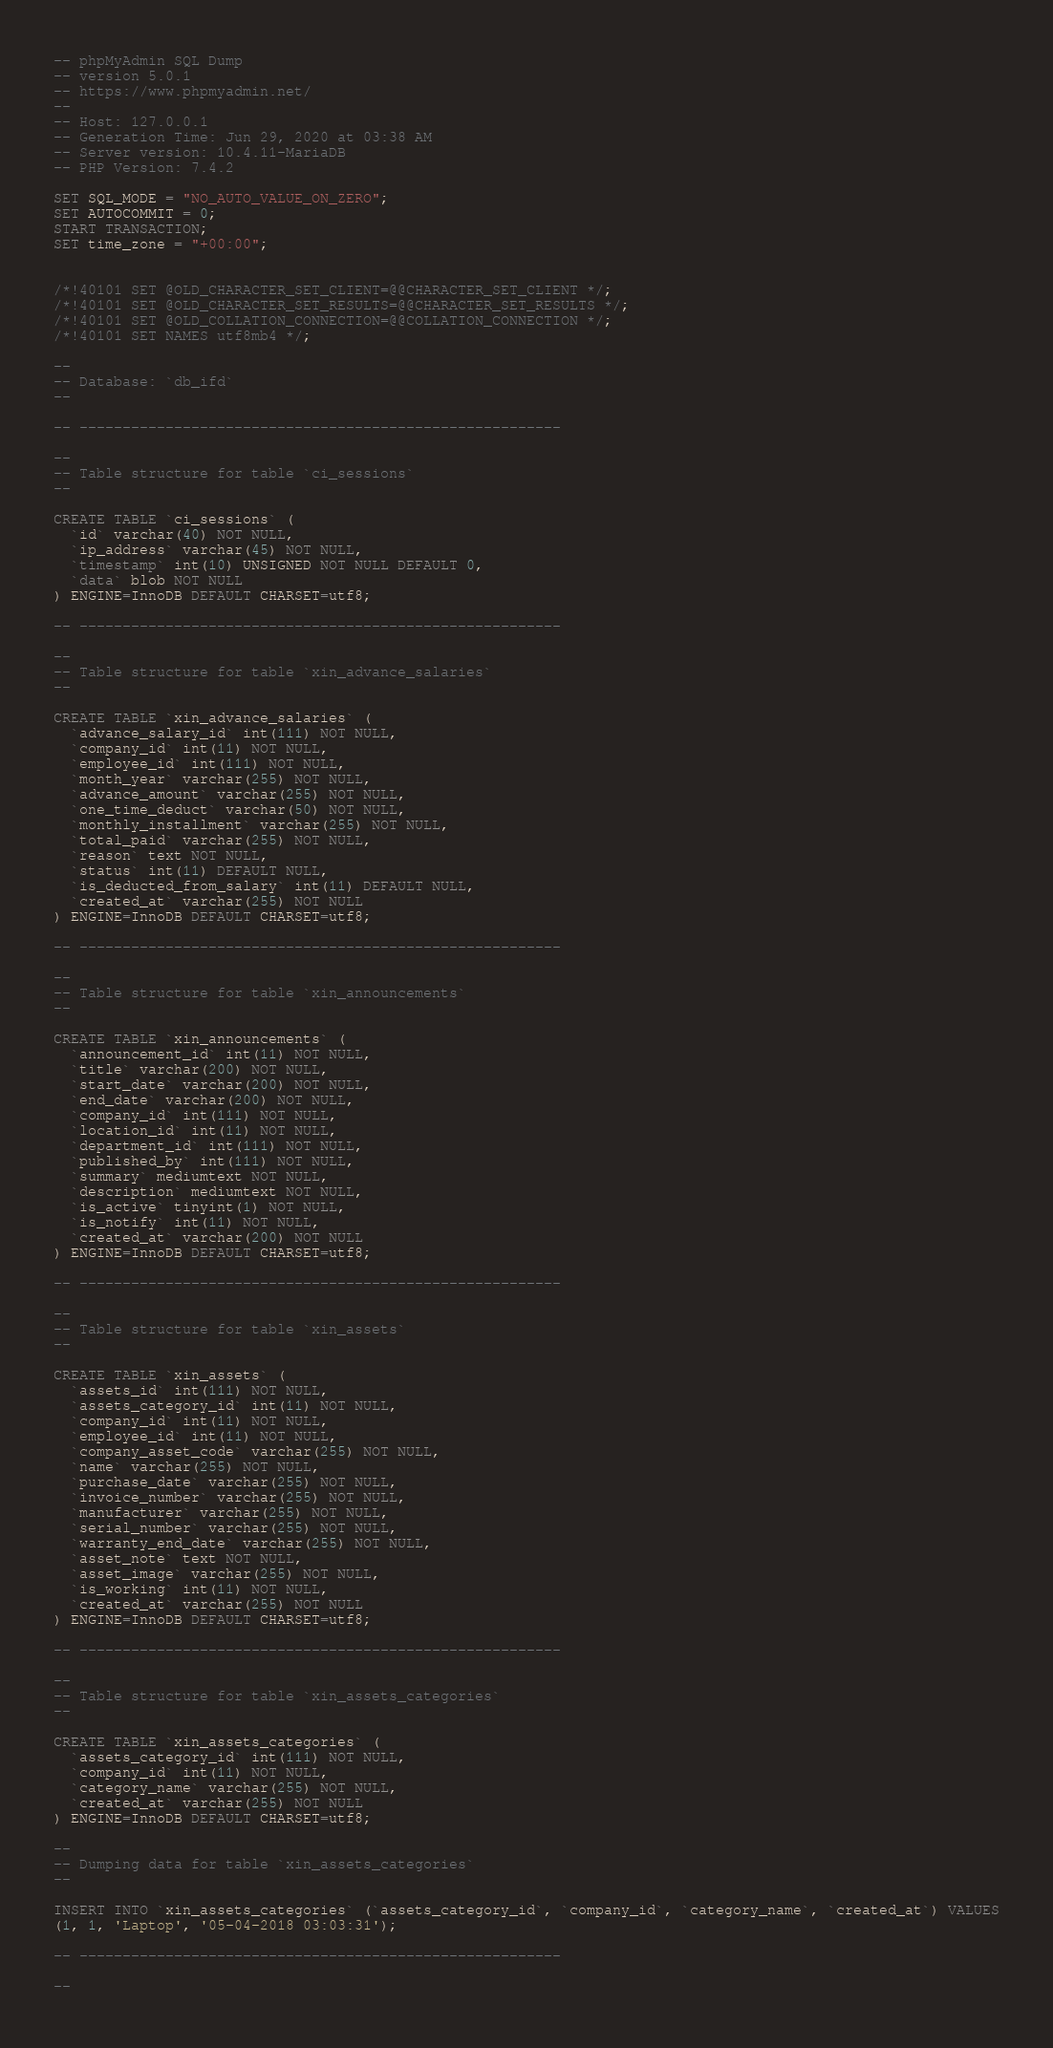<code> <loc_0><loc_0><loc_500><loc_500><_SQL_>-- phpMyAdmin SQL Dump
-- version 5.0.1
-- https://www.phpmyadmin.net/
--
-- Host: 127.0.0.1
-- Generation Time: Jun 29, 2020 at 03:38 AM
-- Server version: 10.4.11-MariaDB
-- PHP Version: 7.4.2

SET SQL_MODE = "NO_AUTO_VALUE_ON_ZERO";
SET AUTOCOMMIT = 0;
START TRANSACTION;
SET time_zone = "+00:00";


/*!40101 SET @OLD_CHARACTER_SET_CLIENT=@@CHARACTER_SET_CLIENT */;
/*!40101 SET @OLD_CHARACTER_SET_RESULTS=@@CHARACTER_SET_RESULTS */;
/*!40101 SET @OLD_COLLATION_CONNECTION=@@COLLATION_CONNECTION */;
/*!40101 SET NAMES utf8mb4 */;

--
-- Database: `db_ifd`
--

-- --------------------------------------------------------

--
-- Table structure for table `ci_sessions`
--

CREATE TABLE `ci_sessions` (
  `id` varchar(40) NOT NULL,
  `ip_address` varchar(45) NOT NULL,
  `timestamp` int(10) UNSIGNED NOT NULL DEFAULT 0,
  `data` blob NOT NULL
) ENGINE=InnoDB DEFAULT CHARSET=utf8;

-- --------------------------------------------------------

--
-- Table structure for table `xin_advance_salaries`
--

CREATE TABLE `xin_advance_salaries` (
  `advance_salary_id` int(111) NOT NULL,
  `company_id` int(11) NOT NULL,
  `employee_id` int(111) NOT NULL,
  `month_year` varchar(255) NOT NULL,
  `advance_amount` varchar(255) NOT NULL,
  `one_time_deduct` varchar(50) NOT NULL,
  `monthly_installment` varchar(255) NOT NULL,
  `total_paid` varchar(255) NOT NULL,
  `reason` text NOT NULL,
  `status` int(11) DEFAULT NULL,
  `is_deducted_from_salary` int(11) DEFAULT NULL,
  `created_at` varchar(255) NOT NULL
) ENGINE=InnoDB DEFAULT CHARSET=utf8;

-- --------------------------------------------------------

--
-- Table structure for table `xin_announcements`
--

CREATE TABLE `xin_announcements` (
  `announcement_id` int(11) NOT NULL,
  `title` varchar(200) NOT NULL,
  `start_date` varchar(200) NOT NULL,
  `end_date` varchar(200) NOT NULL,
  `company_id` int(111) NOT NULL,
  `location_id` int(11) NOT NULL,
  `department_id` int(111) NOT NULL,
  `published_by` int(111) NOT NULL,
  `summary` mediumtext NOT NULL,
  `description` mediumtext NOT NULL,
  `is_active` tinyint(1) NOT NULL,
  `is_notify` int(11) NOT NULL,
  `created_at` varchar(200) NOT NULL
) ENGINE=InnoDB DEFAULT CHARSET=utf8;

-- --------------------------------------------------------

--
-- Table structure for table `xin_assets`
--

CREATE TABLE `xin_assets` (
  `assets_id` int(111) NOT NULL,
  `assets_category_id` int(11) NOT NULL,
  `company_id` int(11) NOT NULL,
  `employee_id` int(11) NOT NULL,
  `company_asset_code` varchar(255) NOT NULL,
  `name` varchar(255) NOT NULL,
  `purchase_date` varchar(255) NOT NULL,
  `invoice_number` varchar(255) NOT NULL,
  `manufacturer` varchar(255) NOT NULL,
  `serial_number` varchar(255) NOT NULL,
  `warranty_end_date` varchar(255) NOT NULL,
  `asset_note` text NOT NULL,
  `asset_image` varchar(255) NOT NULL,
  `is_working` int(11) NOT NULL,
  `created_at` varchar(255) NOT NULL
) ENGINE=InnoDB DEFAULT CHARSET=utf8;

-- --------------------------------------------------------

--
-- Table structure for table `xin_assets_categories`
--

CREATE TABLE `xin_assets_categories` (
  `assets_category_id` int(111) NOT NULL,
  `company_id` int(11) NOT NULL,
  `category_name` varchar(255) NOT NULL,
  `created_at` varchar(255) NOT NULL
) ENGINE=InnoDB DEFAULT CHARSET=utf8;

--
-- Dumping data for table `xin_assets_categories`
--

INSERT INTO `xin_assets_categories` (`assets_category_id`, `company_id`, `category_name`, `created_at`) VALUES
(1, 1, 'Laptop', '05-04-2018 03:03:31');

-- --------------------------------------------------------

--</code> 